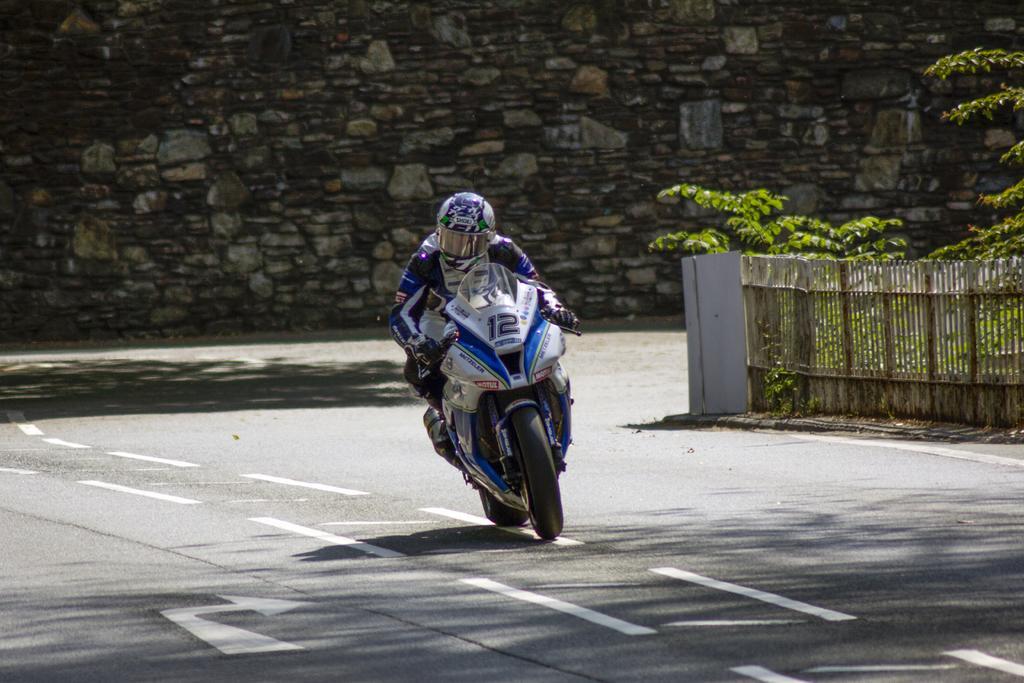Could you give a brief overview of what you see in this image? In this image I can see a person riding a motorcycle on the road. He is wearing a helmet, gloves and a jacket. There are plants and a fence on the right. There is a stone wall at the back. 